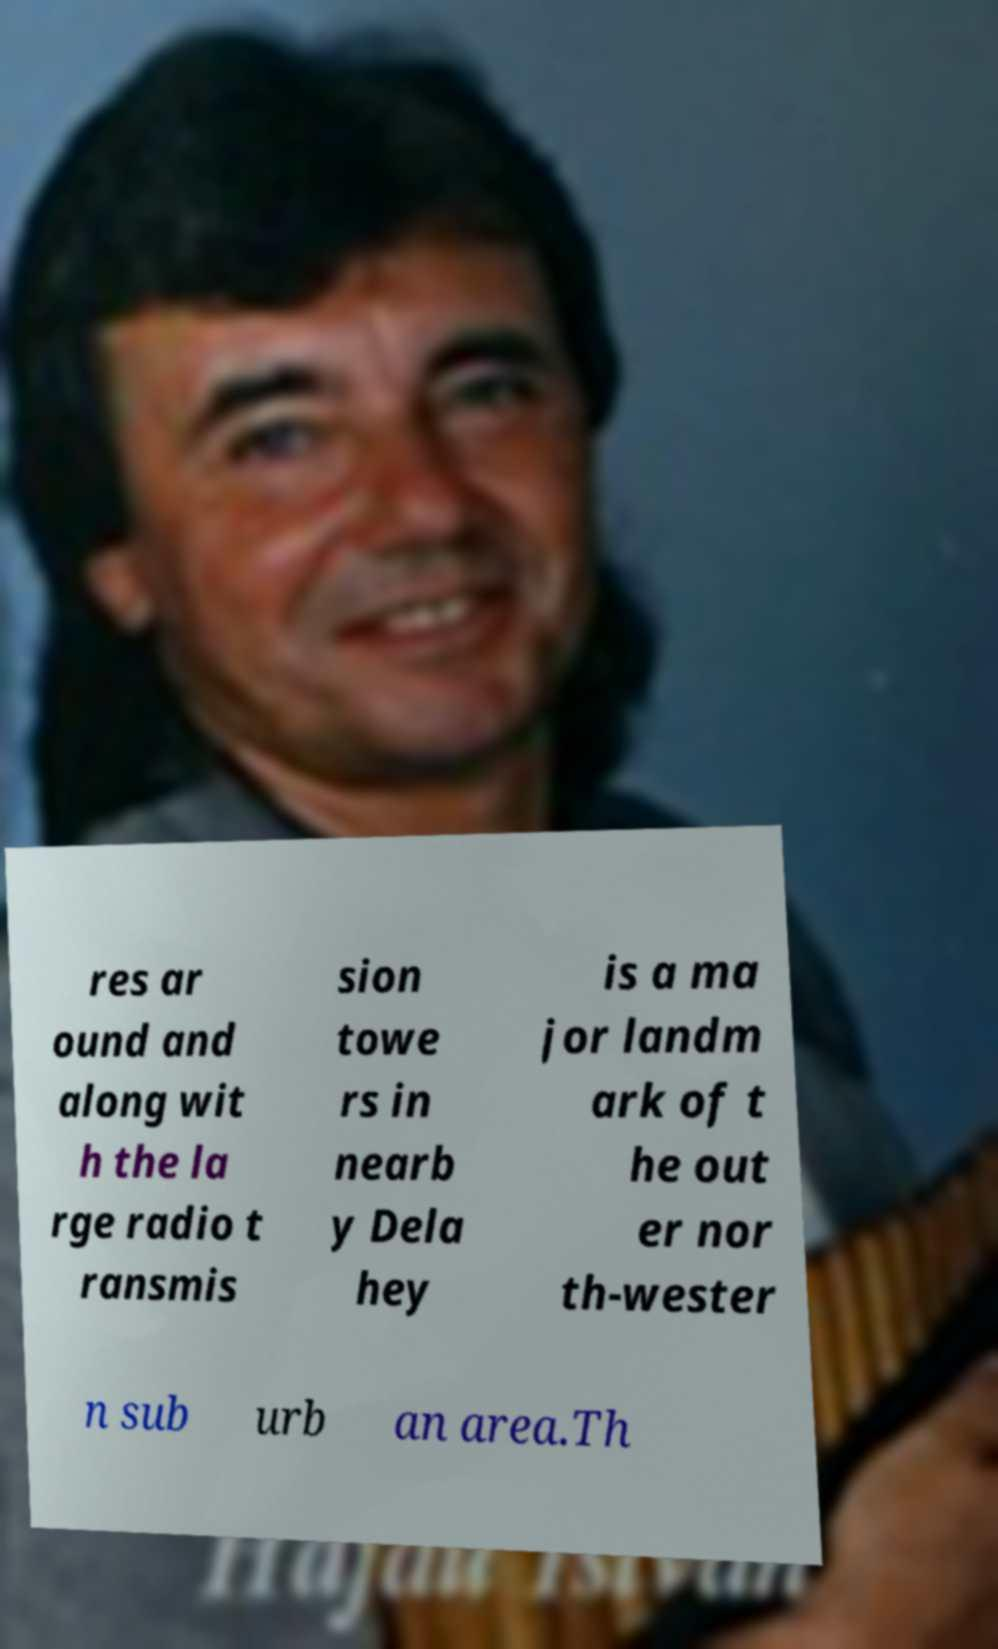Can you accurately transcribe the text from the provided image for me? res ar ound and along wit h the la rge radio t ransmis sion towe rs in nearb y Dela hey is a ma jor landm ark of t he out er nor th-wester n sub urb an area.Th 